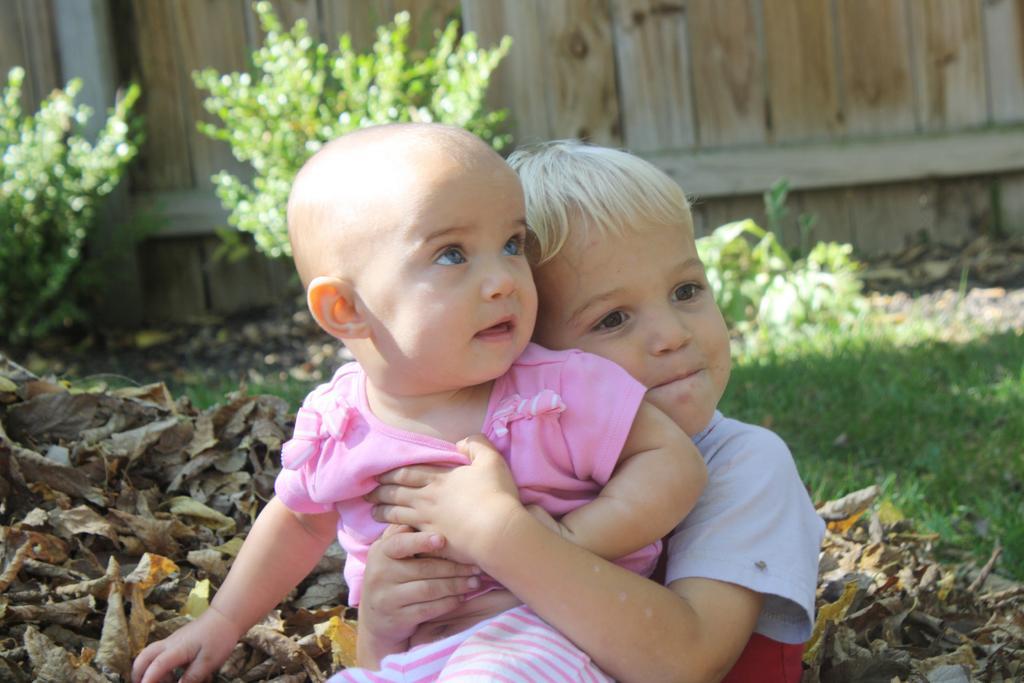How would you summarize this image in a sentence or two? In this picture we can see a kid is sitting on the boy. This boy is holding a kid with his hands. We can see a few dry leaves from left to right. Some grass is visible on the ground. We can see a few plants and a wooden object in the background. 